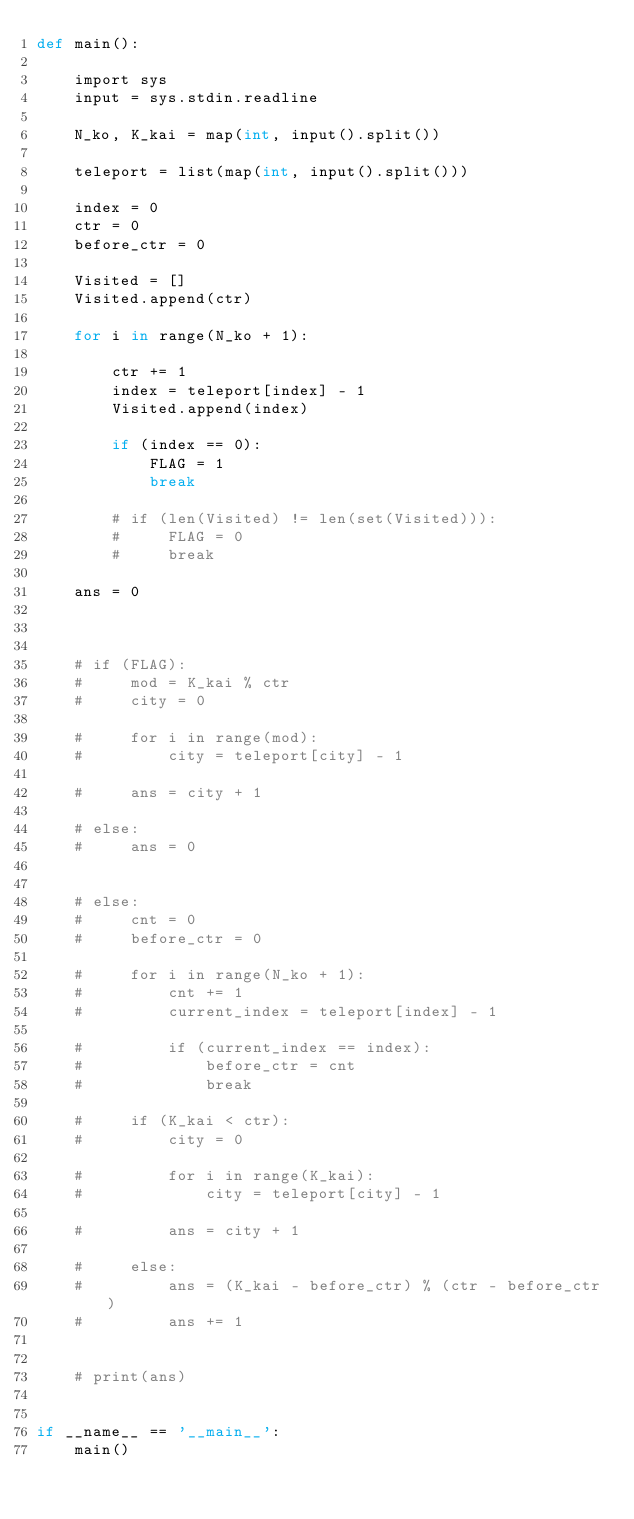Convert code to text. <code><loc_0><loc_0><loc_500><loc_500><_Cython_>def main():

    import sys
    input = sys.stdin.readline

    N_ko, K_kai = map(int, input().split())
    
    teleport = list(map(int, input().split()))

    index = 0
    ctr = 0
    before_ctr = 0

    Visited = []
    Visited.append(ctr)

    for i in range(N_ko + 1):

        ctr += 1
        index = teleport[index] - 1
        Visited.append(index)
        
        if (index == 0):
            FLAG = 1
            break

        # if (len(Visited) != len(set(Visited))):
        #     FLAG = 0
        #     break
    
    ans = 0
    


    # if (FLAG):
    #     mod = K_kai % ctr
    #     city = 0

    #     for i in range(mod):
    #         city = teleport[city] - 1

    #     ans = city + 1
    
    # else:
    #     ans = 0


    # else:
    #     cnt = 0
    #     before_ctr = 0

    #     for i in range(N_ko + 1):
    #         cnt += 1
    #         current_index = teleport[index] - 1
            
    #         if (current_index == index):
    #             before_ctr = cnt
    #             break
        
    #     if (K_kai < ctr):
    #         city = 0
            
    #         for i in range(K_kai):
    #             city = teleport[city] - 1

    #         ans = city + 1

    #     else:
    #         ans = (K_kai - before_ctr) % (ctr - before_ctr)
    #         ans += 1
            

    # print(ans)


if __name__ == '__main__':
    main()</code> 